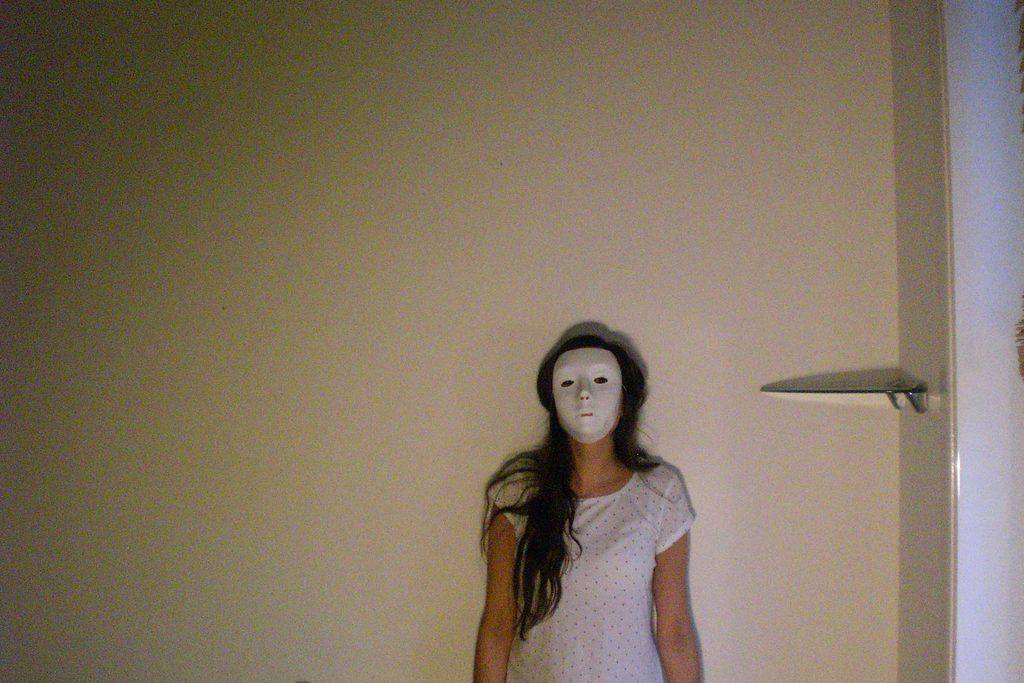Who is in the image? There is a girl in the image. Where is the girl positioned in relation to the wall? The girl is standing near a wall. What is the girl wearing on her face? The girl is wearing a mask. What can be seen on the right side of the image? There is a shelf on the right side of the image. How is the shelf connected to the wall? The shelf is attached to the wall. What type of bubble can be seen floating near the girl in the image? There is no bubble present in the image. Is there a train visible in the image? No, there is no train visible in the image. 